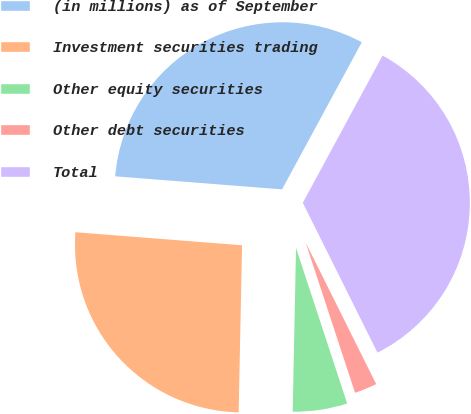Convert chart to OTSL. <chart><loc_0><loc_0><loc_500><loc_500><pie_chart><fcel>(in millions) as of September<fcel>Investment securities trading<fcel>Other equity securities<fcel>Other debt securities<fcel>Total<nl><fcel>31.66%<fcel>25.92%<fcel>5.38%<fcel>2.3%<fcel>34.74%<nl></chart> 